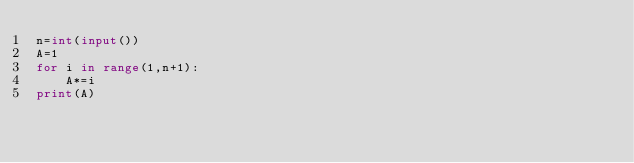Convert code to text. <code><loc_0><loc_0><loc_500><loc_500><_Python_>n=int(input())
A=1
for i in range(1,n+1):
    A*=i
print(A)
</code> 